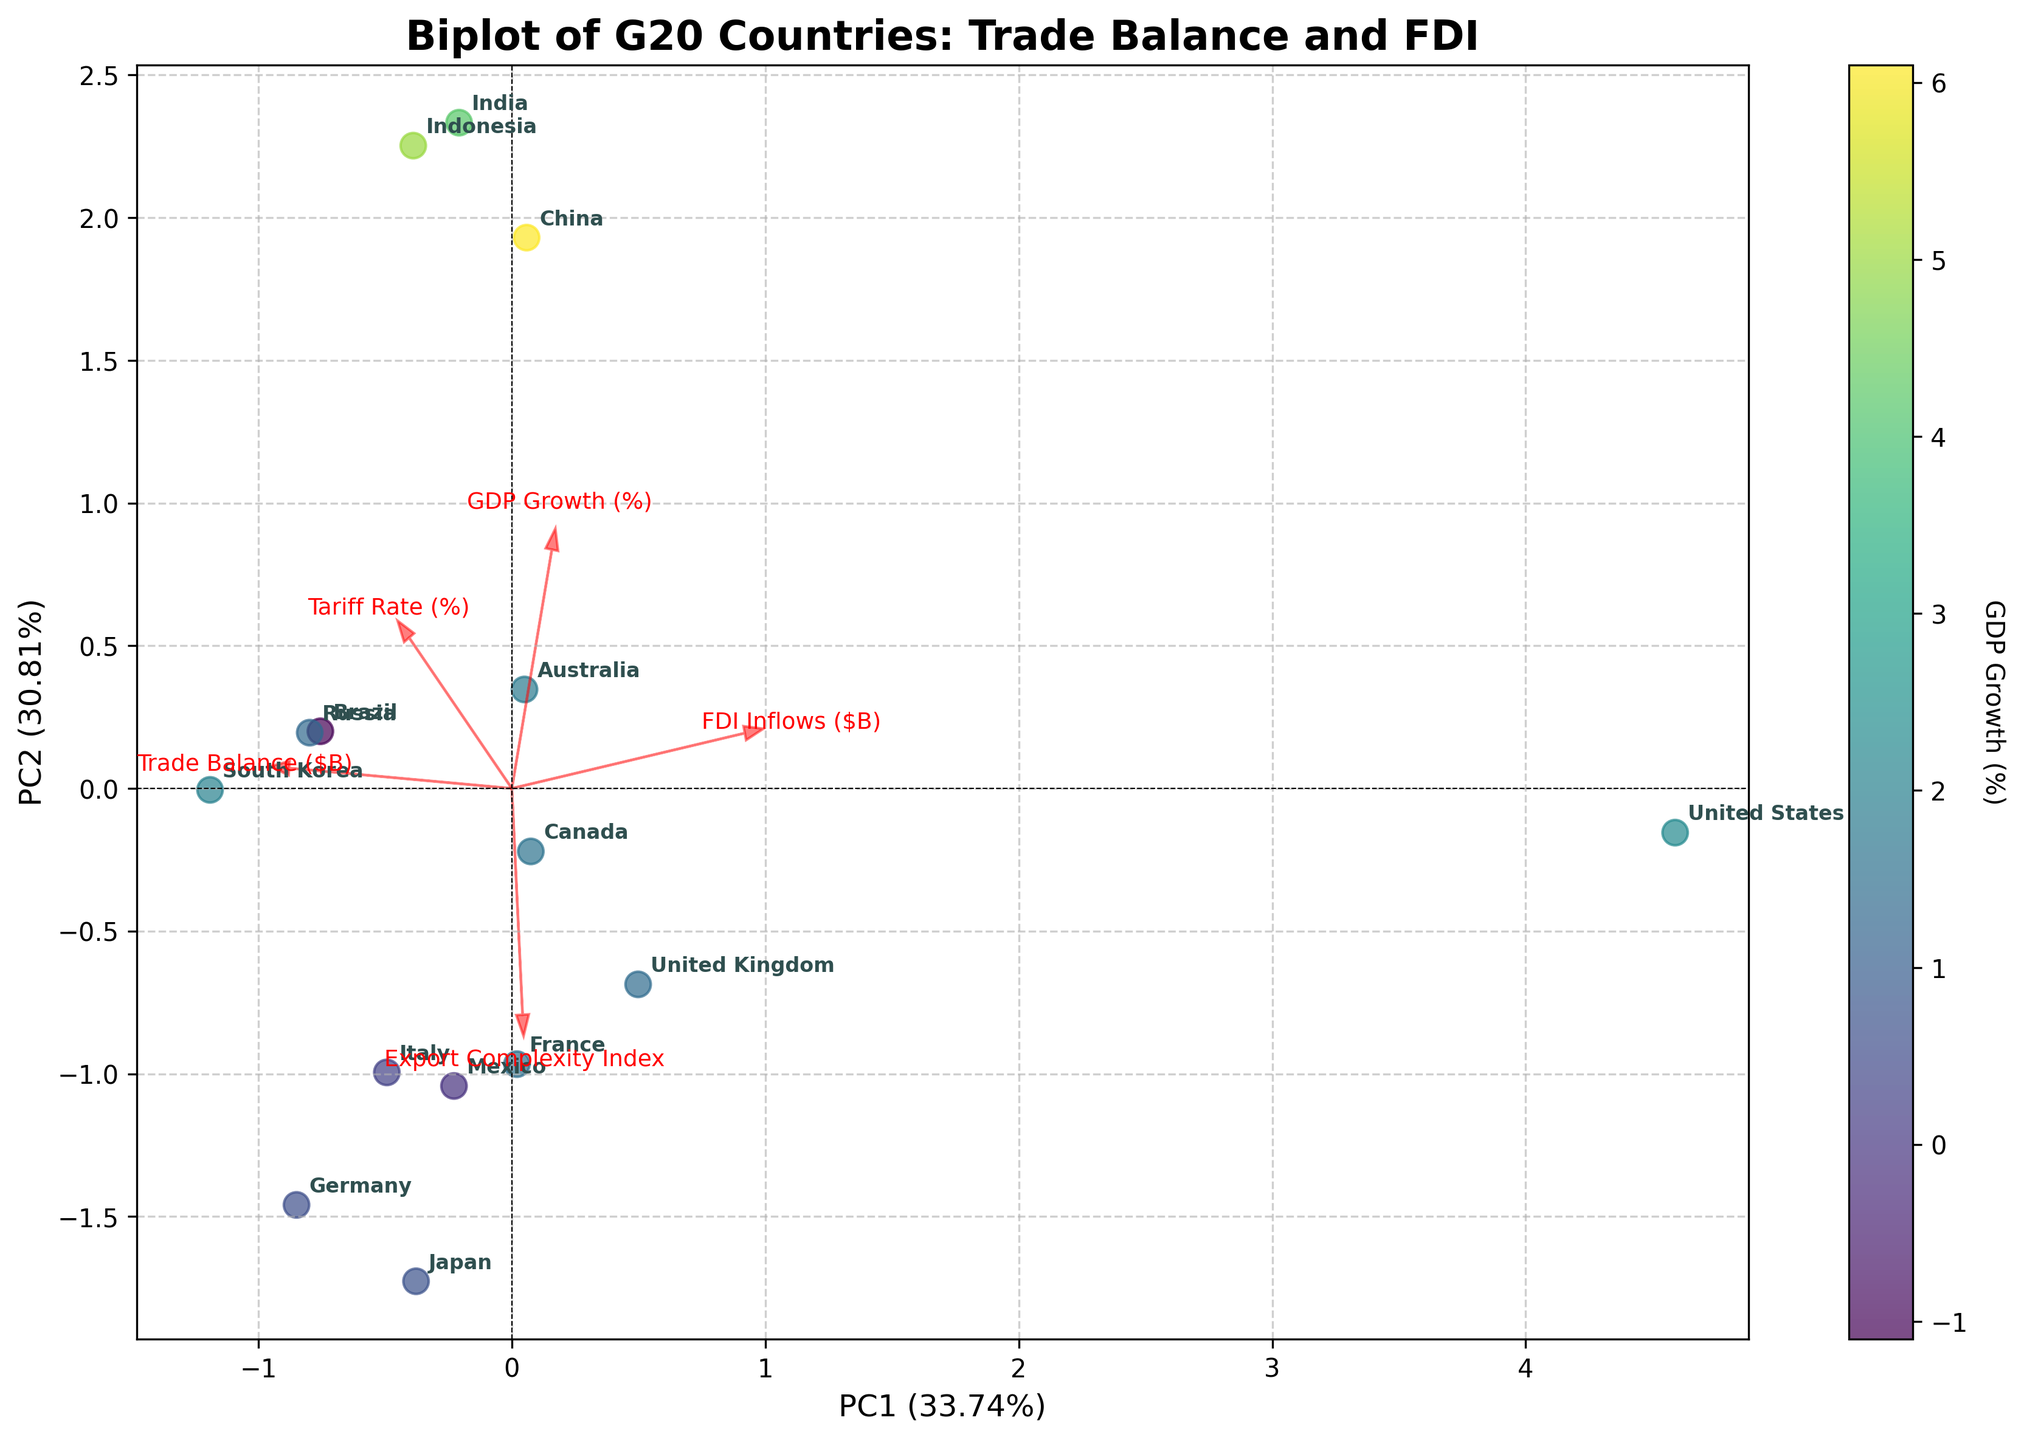What is the title of the biplot? The title of the biplot is typically displayed at the top of the figure. It provides a summary of what the plot represents.
Answer: Biplot of G20 Countries: Trade Balance and FDI How many countries are represented in the biplot? You can count the number of unique data points that are labeled with country names in the biplot, each representing a G20 country.
Answer: 15 Which country's data point has the highest GDP growth percentage? The color of the data points represents GDP growth percentage, with the biplot legend indicating that higher values are shown in brighter colors. By identifying the brightest data point and its corresponding label, you can determine the country.
Answer: China Which G20 country is closest to the origin in the biplot? The origin of the biplot is where the two principal component axes intersect (0,0). The country closest to this point can be identified by finding the labeled data point nearest to the origin.
Answer: Mexico Which feature has the largest loading on the first principal component? Loading vectors on the biplot represent the correlation between the original features and the principal components. Determine which red arrow is the longest in the direction of the first principal component (x-axis).
Answer: Trade Balance ($B) Which two G20 countries have a similar trade balance and FDI Inflows according to the biplot? Look for countries that are positioned close to each other in the principal component space, indicating similar values for trade balance and FDI inflows.
Answer: France and Italy Based on the biplot, which feature is most correlated with PC2? By observing the loading vectors, identify which arrow is most aligned vertically (pointing up or down), as the vertical direction represents the second principal component (y-axis).
Answer: Tariff Rate (%) Which country shows a negative trade balance but positive FDI inflows and what are its coordinates on the biplot? Identify the country with a labeled data point to the left of the origin (indicating negative trade balance) but above the origin (indicating positive FDI inflows). Then note its position on the biplot.
Answer: United Kingdom, approximately (-1, 0.5) Which feature appears to be the least important in explaining the variance among the G20 countries? The importance of a feature in PCA is reflected in the length of its loading vector. The shorter the arrow, the less it contributes to the principal components.
Answer: Export Complexity Index What is the relationship between GDP growth and the first principal component for the G20 countries? This can be inferred by examining the color gradient from left to right on the x-axis. Determine if the colors indicate an increasing or decreasing trend from left to right.
Answer: Generally increasing 